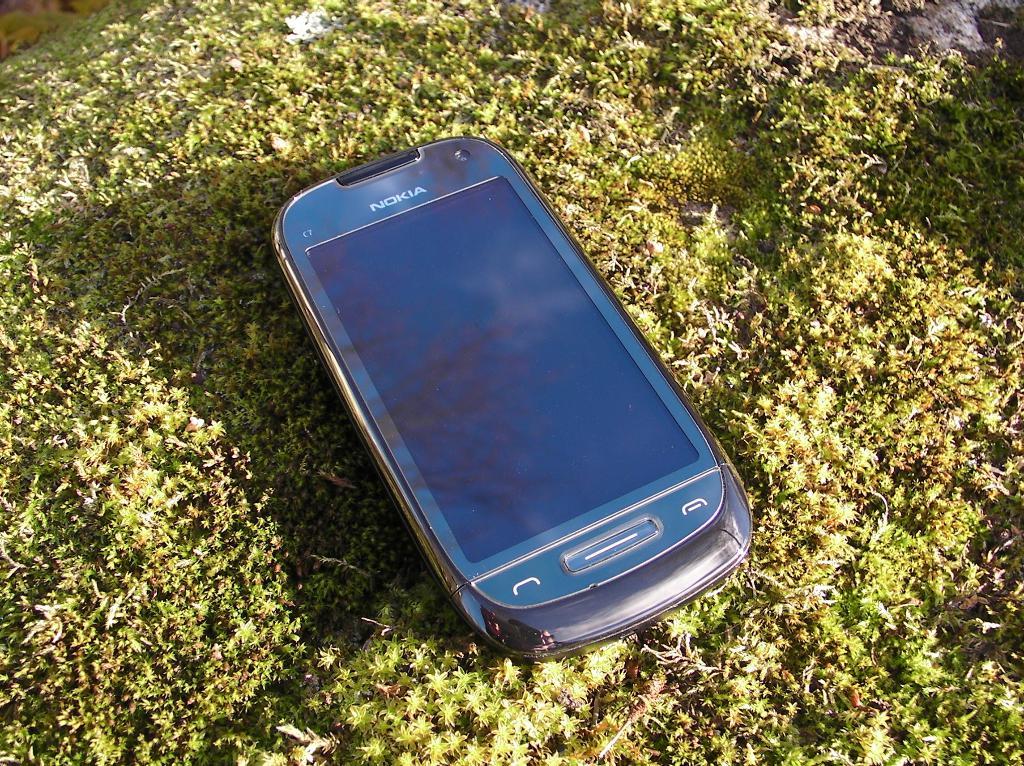What brand of cell phone is this?
Offer a terse response. Nokia. 